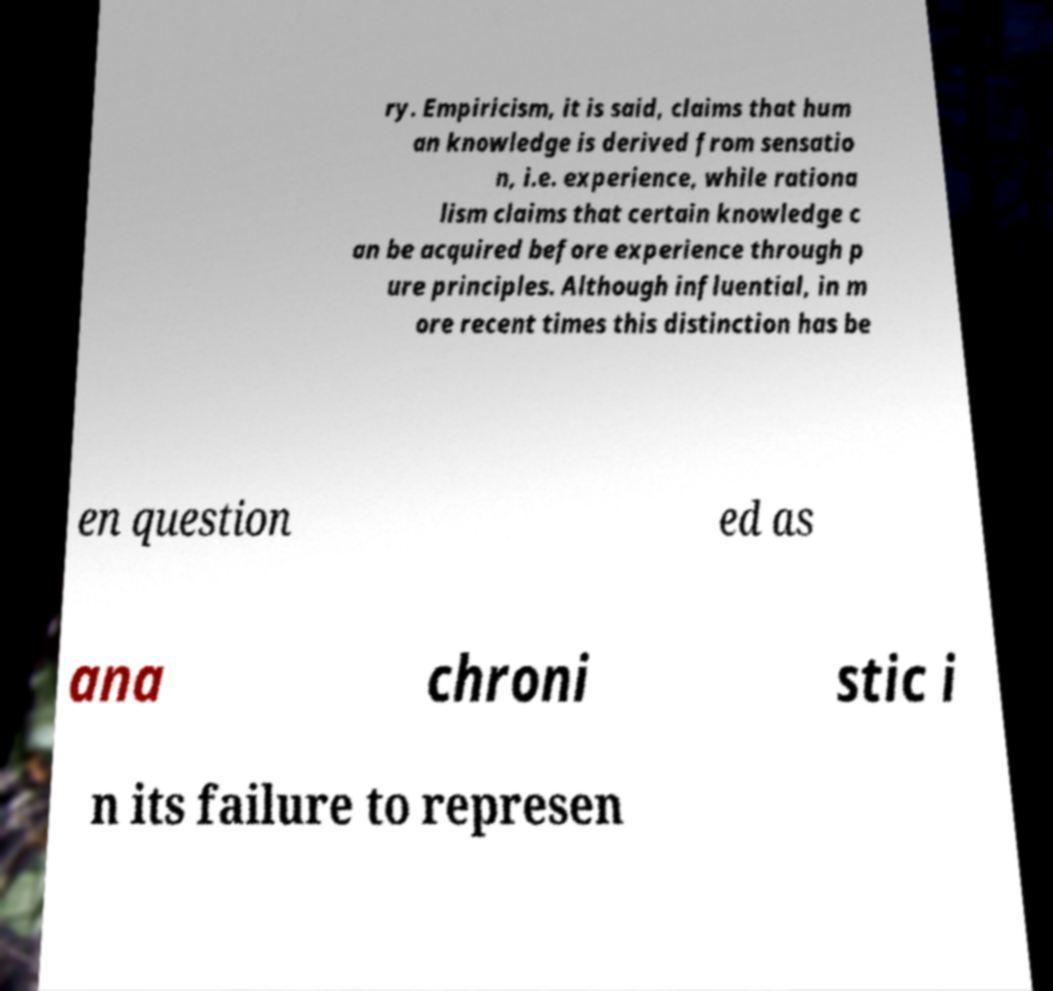What messages or text are displayed in this image? I need them in a readable, typed format. ry. Empiricism, it is said, claims that hum an knowledge is derived from sensatio n, i.e. experience, while rationa lism claims that certain knowledge c an be acquired before experience through p ure principles. Although influential, in m ore recent times this distinction has be en question ed as ana chroni stic i n its failure to represen 